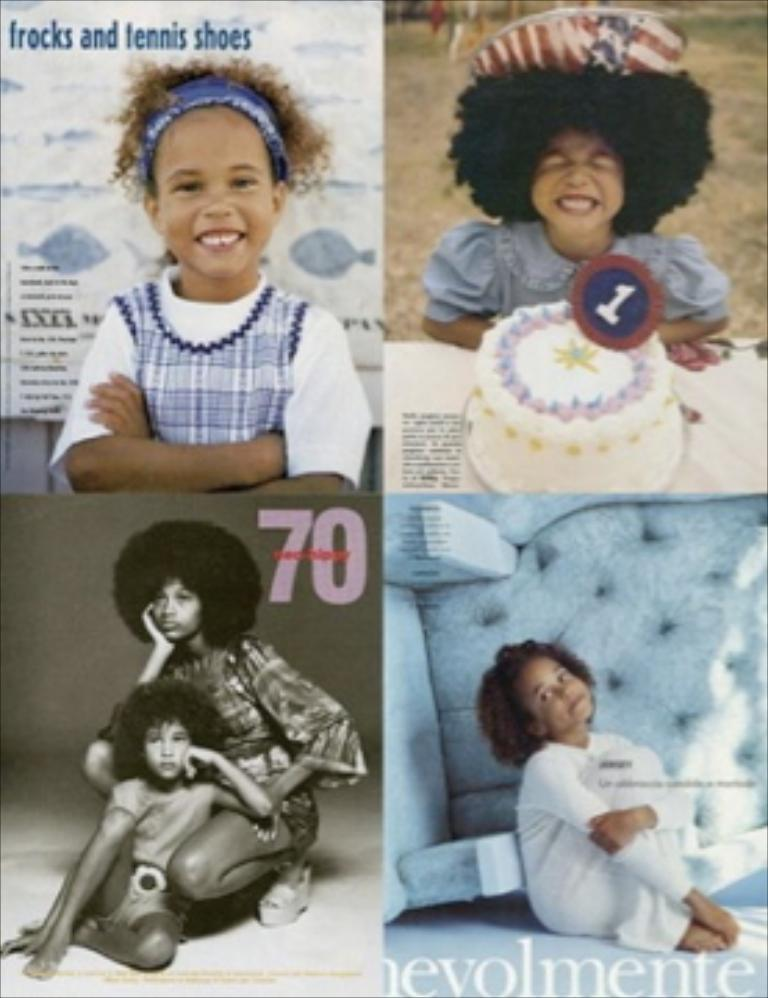What is the main subject of the image? The main subject of the image is a collage of pictures. What type of pictures are included in the collage? The collage contains pictures of a group of children. Are there any words or letters on the collage? Yes, there is text present on the collage. What type of tin can be seen in the image? There is no tin present in the image. Is there a lamp visible in the image? No, there is no lamp visible in the image. Can you see a clam in any of the pictures in the collage? No, there are no clams visible in any of the pictures in the collage. 